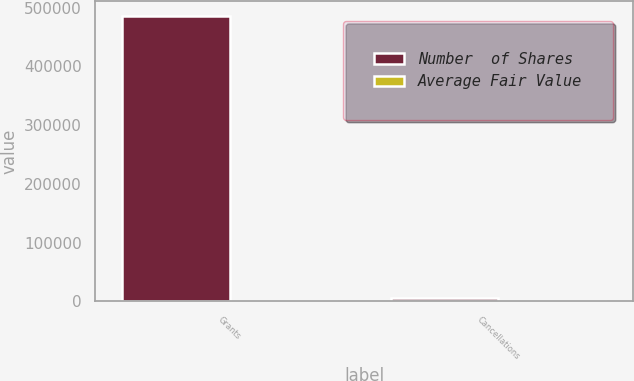<chart> <loc_0><loc_0><loc_500><loc_500><stacked_bar_chart><ecel><fcel>Grants<fcel>Cancellations<nl><fcel>Number  of Shares<fcel>486500<fcel>6500<nl><fcel>Average Fair Value<fcel>25.86<fcel>25.6<nl></chart> 